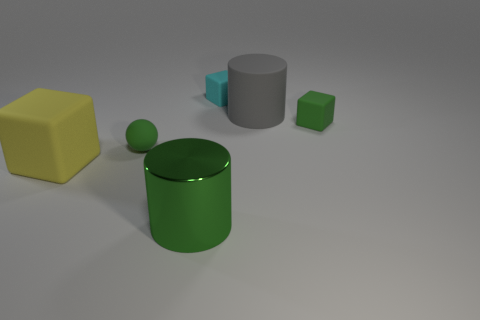Is there any other thing that is the same material as the big green cylinder?
Make the answer very short. No. There is a yellow object; does it have the same size as the cylinder that is on the left side of the gray matte thing?
Give a very brief answer. Yes. There is a cyan rubber thing behind the big matte object on the right side of the large matte object that is left of the gray cylinder; what is its size?
Give a very brief answer. Small. What is the size of the block that is behind the green block?
Your response must be concise. Small. There is a small cyan object that is made of the same material as the large yellow thing; what shape is it?
Make the answer very short. Cube. Is the small cyan object behind the green matte sphere made of the same material as the big green thing?
Provide a succinct answer. No. What number of other objects are the same material as the large gray cylinder?
Offer a terse response. 4. How many objects are green things that are left of the shiny cylinder or large matte objects that are behind the yellow block?
Provide a succinct answer. 2. Is the shape of the green object that is in front of the green sphere the same as the large object to the right of the big green thing?
Give a very brief answer. Yes. There is a green object that is the same size as the green matte block; what is its shape?
Your answer should be very brief. Sphere. 